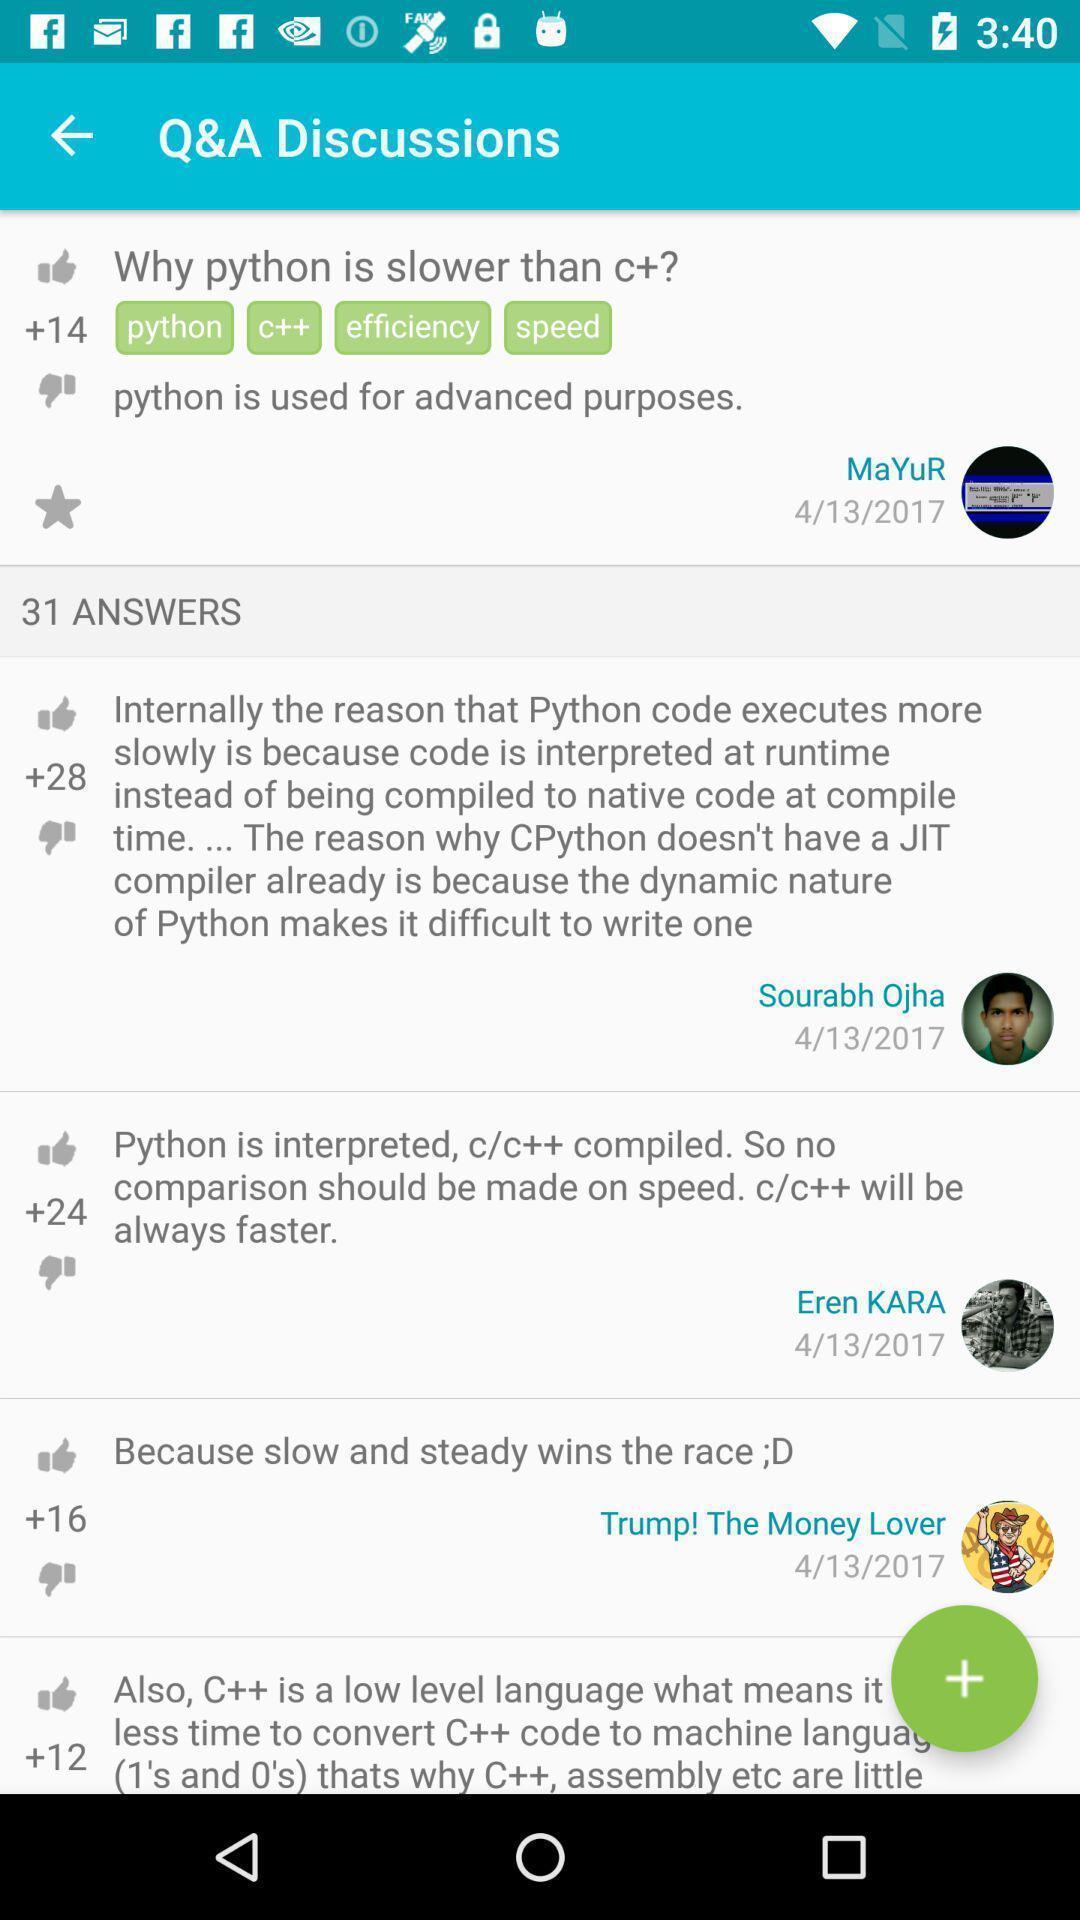Describe this image in words. Screen shows q a discussions in programming course. 